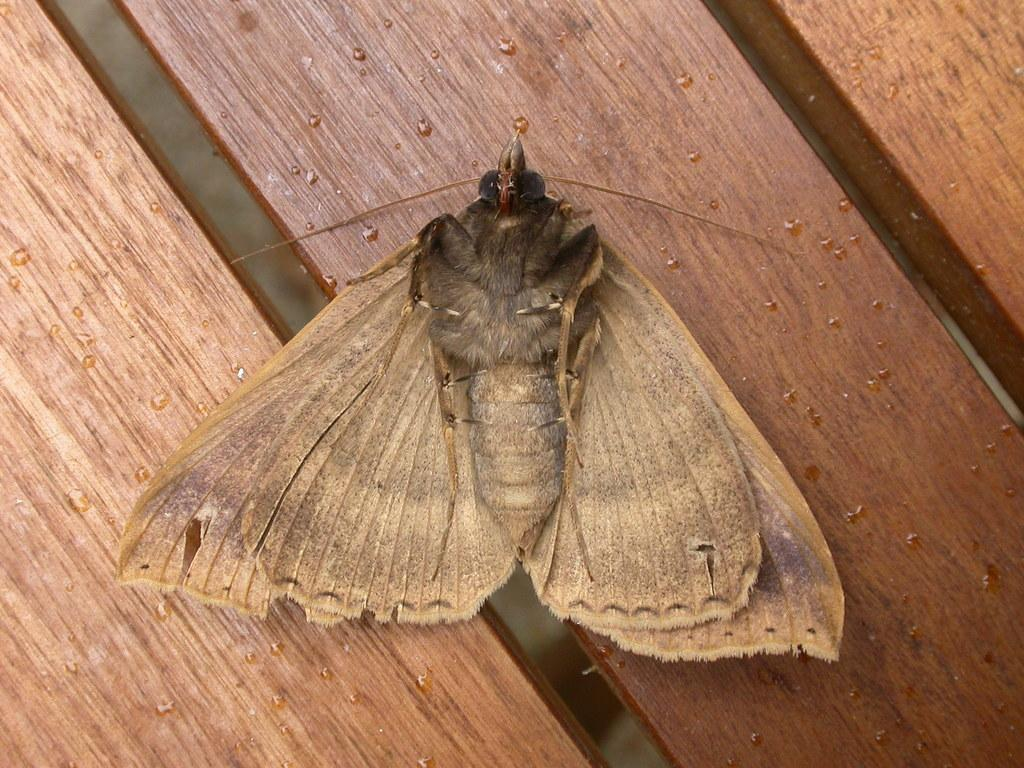What is on the wooden board in the image? There is a butterfly on a wooden board in the image. What else can be seen in the image besides the butterfly? There are water boards visible in the image. What type of pets are visible in the image? There are no pets visible in the image; it features a butterfly on a wooden board and water boards. What time of day is it in the image? The time of day is not mentioned or depicted in the image, so it cannot be determined. 